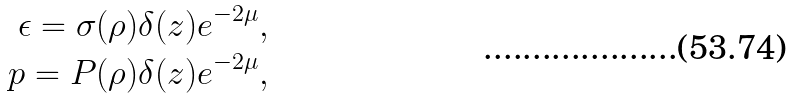<formula> <loc_0><loc_0><loc_500><loc_500>\epsilon = \sigma ( \rho ) \delta ( z ) e ^ { - 2 \mu } , \\ p = P ( \rho ) \delta ( z ) e ^ { - 2 \mu } ,</formula> 